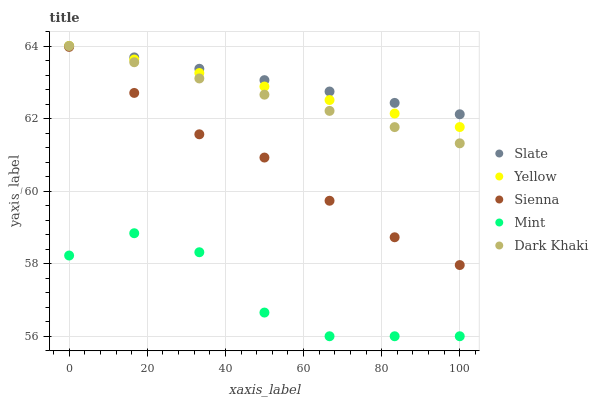Does Mint have the minimum area under the curve?
Answer yes or no. Yes. Does Slate have the maximum area under the curve?
Answer yes or no. Yes. Does Dark Khaki have the minimum area under the curve?
Answer yes or no. No. Does Dark Khaki have the maximum area under the curve?
Answer yes or no. No. Is Dark Khaki the smoothest?
Answer yes or no. Yes. Is Mint the roughest?
Answer yes or no. Yes. Is Slate the smoothest?
Answer yes or no. No. Is Slate the roughest?
Answer yes or no. No. Does Mint have the lowest value?
Answer yes or no. Yes. Does Dark Khaki have the lowest value?
Answer yes or no. No. Does Yellow have the highest value?
Answer yes or no. Yes. Does Mint have the highest value?
Answer yes or no. No. Is Sienna less than Dark Khaki?
Answer yes or no. Yes. Is Sienna greater than Mint?
Answer yes or no. Yes. Does Yellow intersect Dark Khaki?
Answer yes or no. Yes. Is Yellow less than Dark Khaki?
Answer yes or no. No. Is Yellow greater than Dark Khaki?
Answer yes or no. No. Does Sienna intersect Dark Khaki?
Answer yes or no. No. 